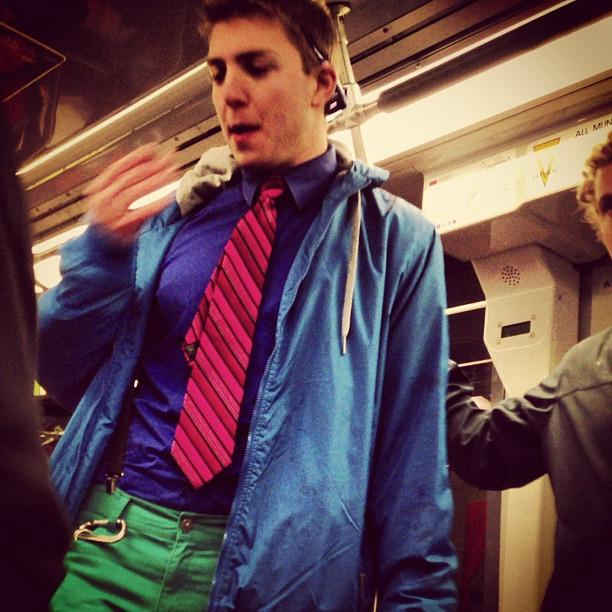What is clipped to the green pants? Please explain your reasoning. carabiner. A carabiner is clipped. 